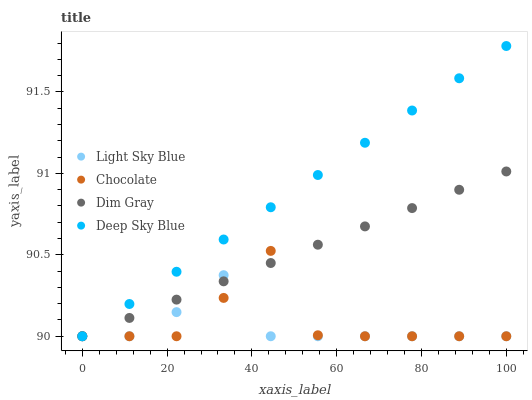Does Light Sky Blue have the minimum area under the curve?
Answer yes or no. Yes. Does Deep Sky Blue have the maximum area under the curve?
Answer yes or no. Yes. Does Deep Sky Blue have the minimum area under the curve?
Answer yes or no. No. Does Light Sky Blue have the maximum area under the curve?
Answer yes or no. No. Is Dim Gray the smoothest?
Answer yes or no. Yes. Is Chocolate the roughest?
Answer yes or no. Yes. Is Light Sky Blue the smoothest?
Answer yes or no. No. Is Light Sky Blue the roughest?
Answer yes or no. No. Does Dim Gray have the lowest value?
Answer yes or no. Yes. Does Deep Sky Blue have the highest value?
Answer yes or no. Yes. Does Light Sky Blue have the highest value?
Answer yes or no. No. Does Chocolate intersect Light Sky Blue?
Answer yes or no. Yes. Is Chocolate less than Light Sky Blue?
Answer yes or no. No. Is Chocolate greater than Light Sky Blue?
Answer yes or no. No. 